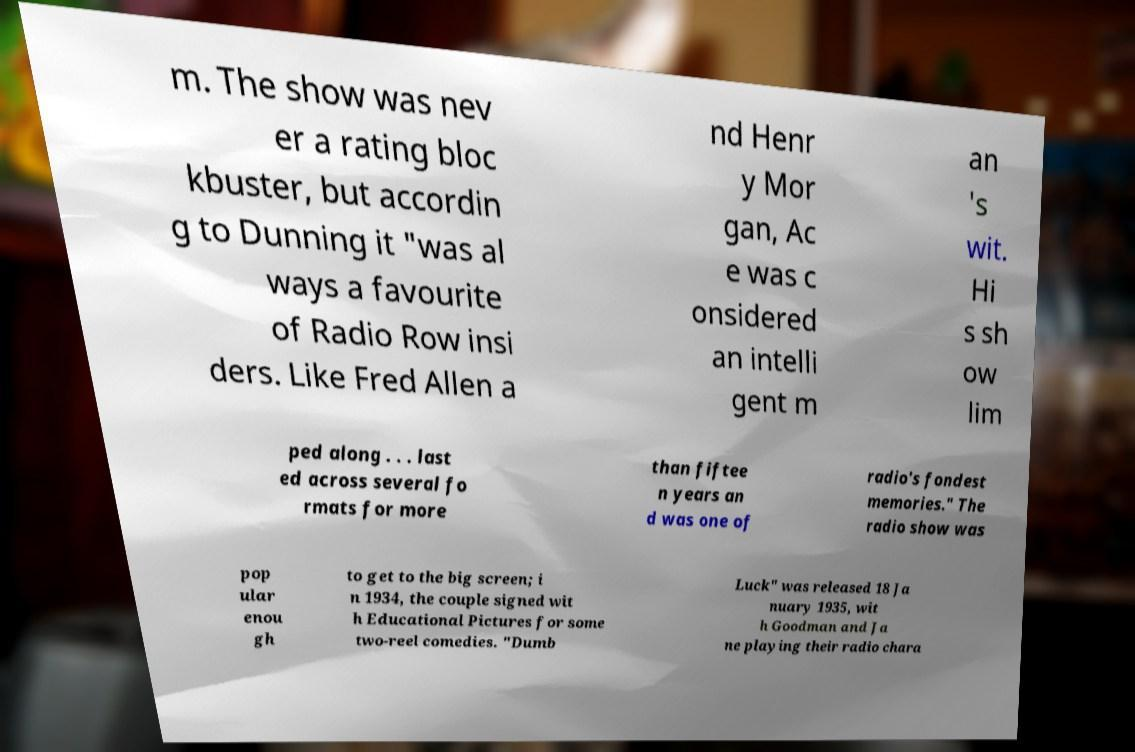Can you accurately transcribe the text from the provided image for me? m. The show was nev er a rating bloc kbuster, but accordin g to Dunning it "was al ways a favourite of Radio Row insi ders. Like Fred Allen a nd Henr y Mor gan, Ac e was c onsidered an intelli gent m an 's wit. Hi s sh ow lim ped along . . . last ed across several fo rmats for more than fiftee n years an d was one of radio's fondest memories." The radio show was pop ular enou gh to get to the big screen; i n 1934, the couple signed wit h Educational Pictures for some two-reel comedies. "Dumb Luck" was released 18 Ja nuary 1935, wit h Goodman and Ja ne playing their radio chara 